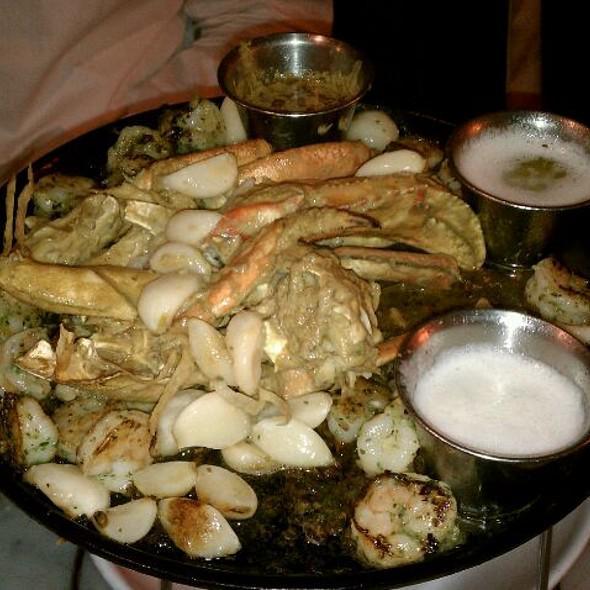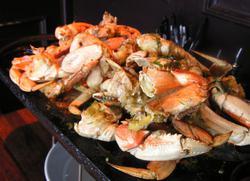The first image is the image on the left, the second image is the image on the right. Analyze the images presented: Is the assertion "One image features crab and two silver bowls of liquid on a round black tray, and the other image features crab on a rectangular black tray." valid? Answer yes or no. Yes. 